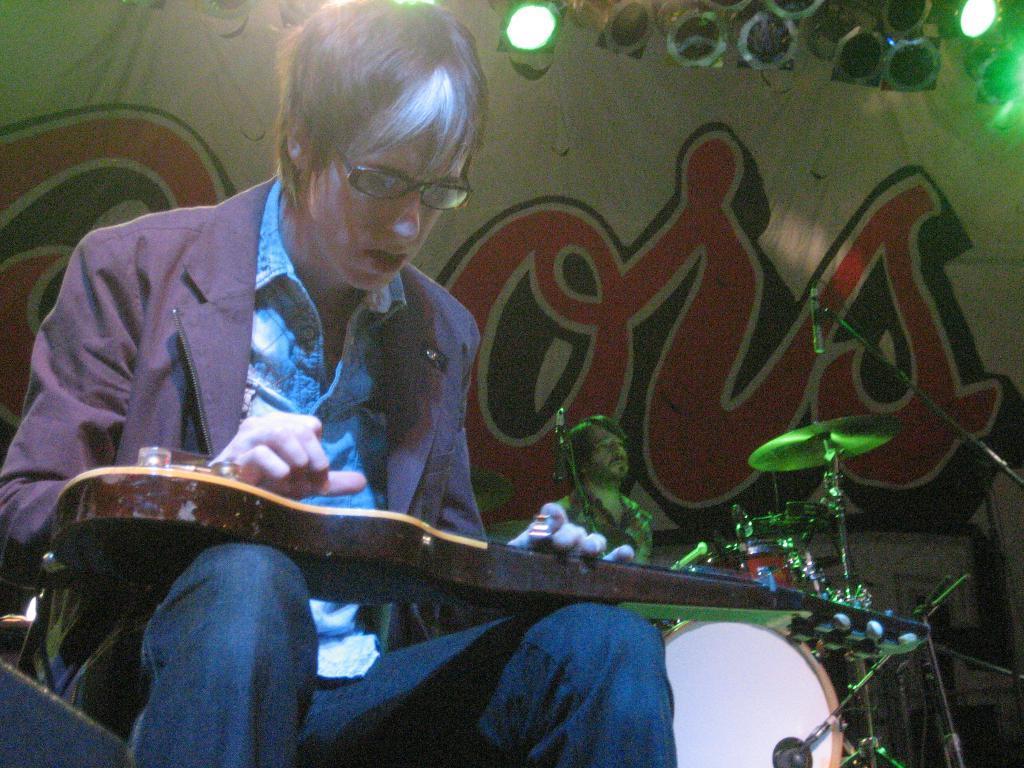In one or two sentences, can you explain what this image depicts? These two persons are sitting. This person holding guitar. This person playing musical instrument. On the background we can see banner,Focusing lights. There is a microphone with stand. 